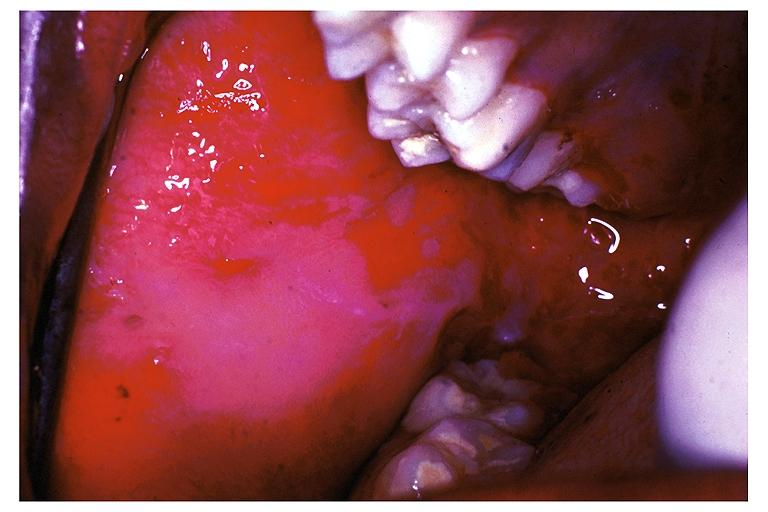does muscle show pemphigus vulgaris?
Answer the question using a single word or phrase. No 